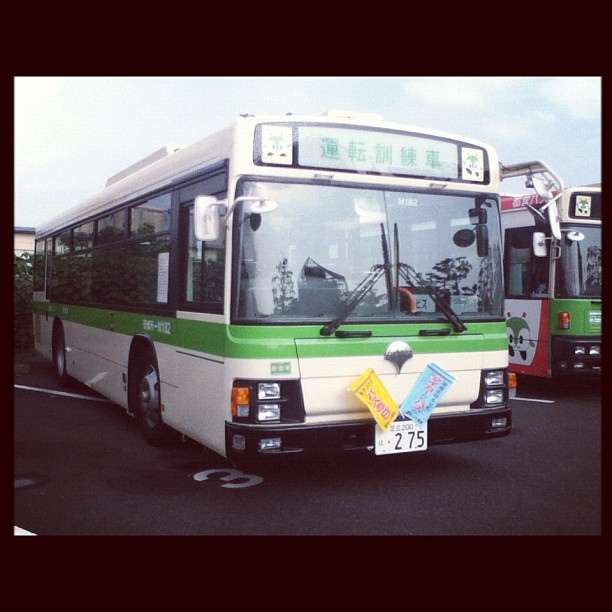<image>What bus station is this? It is unknown what bus station is this. It can be located in China, Chicago, Tokyo or it could be a greyhound or metro station. What is the route listed on the front of the bus? The route listed on the front of the bus is unknown or could be in a foreign language. What bus station is this? I don't know what bus station this is. It can be any of 'china', 'chinese', 'chicago', 'unknown', 'asian', 'greyhound', 'tokyo', or 'metro'. What is the route listed on the front of the bus? The route listed on the front of the bus is unknown. It can be seen 'china', '2.75', '2', 'it's in foreign language', 'unknown', 'chinese', or '275'. 